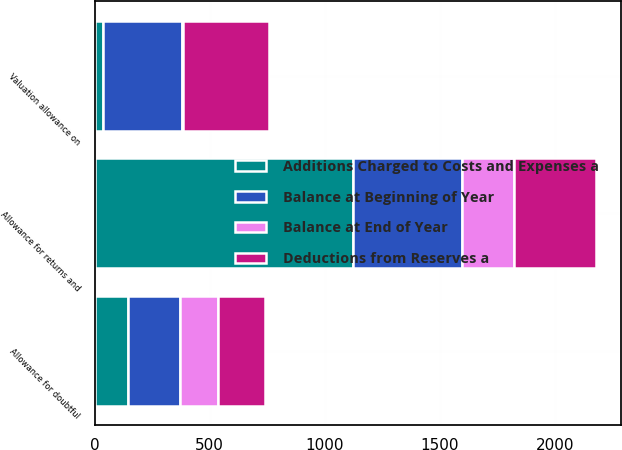<chart> <loc_0><loc_0><loc_500><loc_500><stacked_bar_chart><ecel><fcel>Allowance for doubtful<fcel>Allowance for returns and<fcel>Valuation allowance on<nl><fcel>Deductions from Reserves a<fcel>205<fcel>359<fcel>375<nl><fcel>Balance at End of Year<fcel>166<fcel>226<fcel>4<nl><fcel>Additions Charged to Costs and Expenses a<fcel>145<fcel>1122<fcel>37<nl><fcel>Balance at Beginning of Year<fcel>226<fcel>473<fcel>342<nl></chart> 